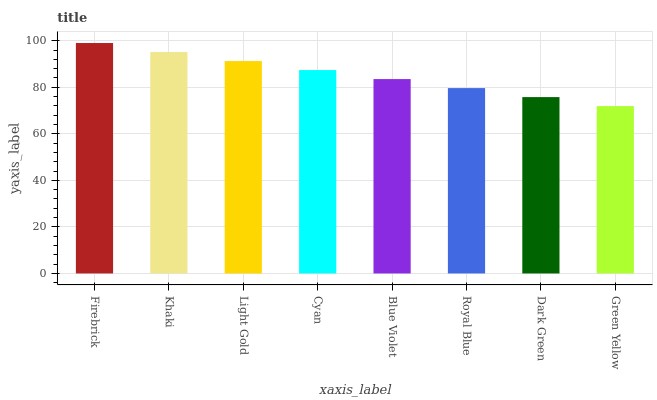Is Green Yellow the minimum?
Answer yes or no. Yes. Is Firebrick the maximum?
Answer yes or no. Yes. Is Khaki the minimum?
Answer yes or no. No. Is Khaki the maximum?
Answer yes or no. No. Is Firebrick greater than Khaki?
Answer yes or no. Yes. Is Khaki less than Firebrick?
Answer yes or no. Yes. Is Khaki greater than Firebrick?
Answer yes or no. No. Is Firebrick less than Khaki?
Answer yes or no. No. Is Cyan the high median?
Answer yes or no. Yes. Is Blue Violet the low median?
Answer yes or no. Yes. Is Blue Violet the high median?
Answer yes or no. No. Is Firebrick the low median?
Answer yes or no. No. 